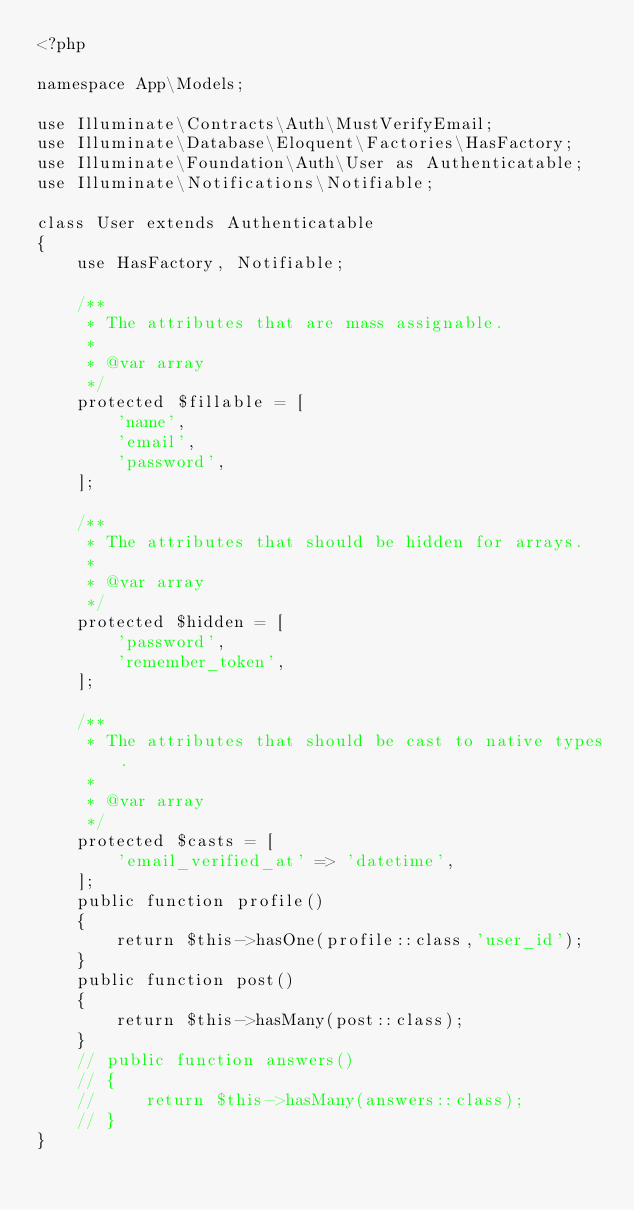<code> <loc_0><loc_0><loc_500><loc_500><_PHP_><?php

namespace App\Models;

use Illuminate\Contracts\Auth\MustVerifyEmail;
use Illuminate\Database\Eloquent\Factories\HasFactory;
use Illuminate\Foundation\Auth\User as Authenticatable;
use Illuminate\Notifications\Notifiable;

class User extends Authenticatable
{
    use HasFactory, Notifiable;

    /**
     * The attributes that are mass assignable.
     *
     * @var array
     */
    protected $fillable = [
        'name',
        'email',
        'password',
    ];

    /**
     * The attributes that should be hidden for arrays.
     *
     * @var array
     */
    protected $hidden = [
        'password',
        'remember_token',
    ];

    /**
     * The attributes that should be cast to native types.
     *
     * @var array
     */
    protected $casts = [
        'email_verified_at' => 'datetime',
    ];
    public function profile()
    {
        return $this->hasOne(profile::class,'user_id');
    }
    public function post()
    {
        return $this->hasMany(post::class);
    }
    // public function answers()
    // {
    //     return $this->hasMany(answers::class);
    // }
}
</code> 